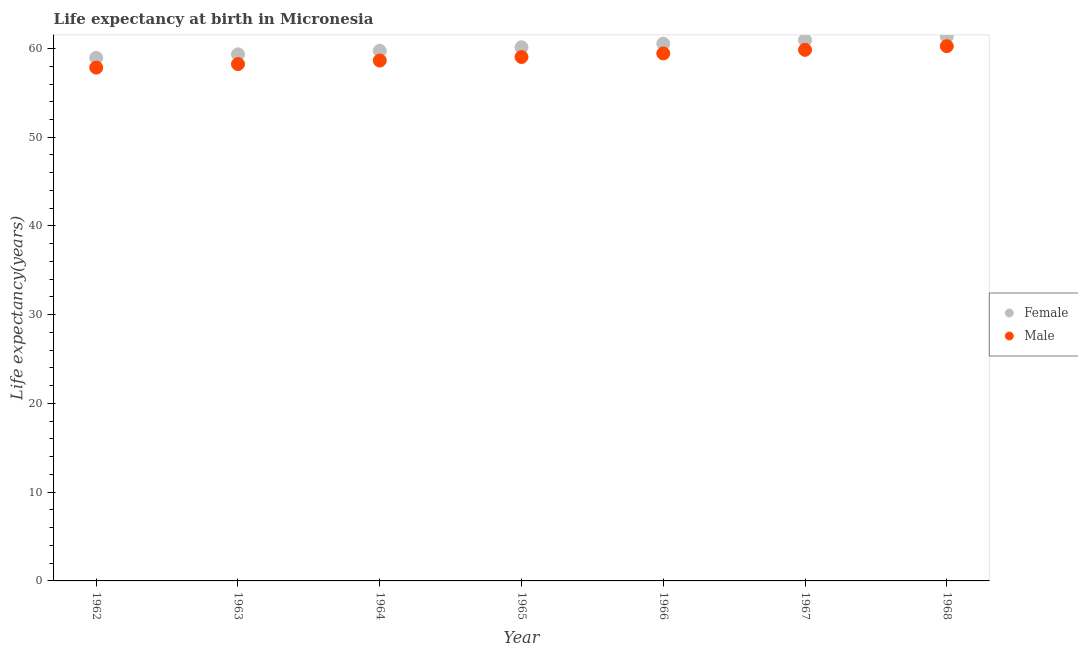What is the life expectancy(female) in 1962?
Your answer should be very brief. 58.95. Across all years, what is the maximum life expectancy(female)?
Keep it short and to the point. 61.36. Across all years, what is the minimum life expectancy(female)?
Give a very brief answer. 58.95. In which year was the life expectancy(female) maximum?
Provide a succinct answer. 1968. What is the total life expectancy(male) in the graph?
Your response must be concise. 413.33. What is the difference between the life expectancy(female) in 1962 and that in 1963?
Your answer should be compact. -0.4. What is the difference between the life expectancy(female) in 1967 and the life expectancy(male) in 1964?
Your response must be concise. 2.31. What is the average life expectancy(female) per year?
Provide a short and direct response. 60.15. In the year 1966, what is the difference between the life expectancy(female) and life expectancy(male)?
Provide a short and direct response. 1.1. In how many years, is the life expectancy(female) greater than 10 years?
Provide a succinct answer. 7. What is the ratio of the life expectancy(female) in 1962 to that in 1965?
Make the answer very short. 0.98. Is the life expectancy(male) in 1963 less than that in 1968?
Your answer should be very brief. Yes. What is the difference between the highest and the second highest life expectancy(male)?
Give a very brief answer. 0.41. What is the difference between the highest and the lowest life expectancy(female)?
Give a very brief answer. 2.41. In how many years, is the life expectancy(female) greater than the average life expectancy(female) taken over all years?
Provide a short and direct response. 3. Is the sum of the life expectancy(female) in 1963 and 1968 greater than the maximum life expectancy(male) across all years?
Give a very brief answer. Yes. Does the life expectancy(male) monotonically increase over the years?
Your response must be concise. Yes. Is the life expectancy(male) strictly less than the life expectancy(female) over the years?
Offer a very short reply. Yes. How many years are there in the graph?
Offer a terse response. 7. What is the difference between two consecutive major ticks on the Y-axis?
Your answer should be very brief. 10. Are the values on the major ticks of Y-axis written in scientific E-notation?
Provide a short and direct response. No. Does the graph contain any zero values?
Your response must be concise. No. How many legend labels are there?
Your answer should be very brief. 2. What is the title of the graph?
Offer a terse response. Life expectancy at birth in Micronesia. Does "Resident" appear as one of the legend labels in the graph?
Make the answer very short. No. What is the label or title of the X-axis?
Make the answer very short. Year. What is the label or title of the Y-axis?
Your answer should be compact. Life expectancy(years). What is the Life expectancy(years) in Female in 1962?
Give a very brief answer. 58.95. What is the Life expectancy(years) in Male in 1962?
Offer a very short reply. 57.85. What is the Life expectancy(years) of Female in 1963?
Your answer should be very brief. 59.34. What is the Life expectancy(years) in Male in 1963?
Offer a terse response. 58.24. What is the Life expectancy(years) in Female in 1964?
Provide a short and direct response. 59.74. What is the Life expectancy(years) of Male in 1964?
Make the answer very short. 58.64. What is the Life expectancy(years) of Female in 1965?
Offer a very short reply. 60.14. What is the Life expectancy(years) of Male in 1965?
Make the answer very short. 59.04. What is the Life expectancy(years) in Female in 1966?
Offer a terse response. 60.55. What is the Life expectancy(years) of Male in 1966?
Give a very brief answer. 59.45. What is the Life expectancy(years) in Female in 1967?
Provide a succinct answer. 60.95. What is the Life expectancy(years) in Male in 1967?
Provide a short and direct response. 59.85. What is the Life expectancy(years) in Female in 1968?
Provide a succinct answer. 61.36. What is the Life expectancy(years) in Male in 1968?
Ensure brevity in your answer.  60.26. Across all years, what is the maximum Life expectancy(years) in Female?
Make the answer very short. 61.36. Across all years, what is the maximum Life expectancy(years) of Male?
Your answer should be compact. 60.26. Across all years, what is the minimum Life expectancy(years) in Female?
Ensure brevity in your answer.  58.95. Across all years, what is the minimum Life expectancy(years) of Male?
Keep it short and to the point. 57.85. What is the total Life expectancy(years) in Female in the graph?
Ensure brevity in your answer.  421.03. What is the total Life expectancy(years) of Male in the graph?
Offer a very short reply. 413.33. What is the difference between the Life expectancy(years) of Female in 1962 and that in 1963?
Provide a succinct answer. -0.4. What is the difference between the Life expectancy(years) in Male in 1962 and that in 1963?
Your answer should be very brief. -0.4. What is the difference between the Life expectancy(years) of Female in 1962 and that in 1964?
Your answer should be very brief. -0.8. What is the difference between the Life expectancy(years) in Male in 1962 and that in 1964?
Provide a succinct answer. -0.8. What is the difference between the Life expectancy(years) of Female in 1962 and that in 1965?
Your answer should be very brief. -1.2. What is the difference between the Life expectancy(years) of Male in 1962 and that in 1965?
Ensure brevity in your answer.  -1.2. What is the difference between the Life expectancy(years) in Female in 1962 and that in 1966?
Ensure brevity in your answer.  -1.6. What is the difference between the Life expectancy(years) of Male in 1962 and that in 1966?
Your answer should be compact. -1.6. What is the difference between the Life expectancy(years) of Female in 1962 and that in 1967?
Provide a short and direct response. -2. What is the difference between the Life expectancy(years) in Male in 1962 and that in 1967?
Provide a succinct answer. -2. What is the difference between the Life expectancy(years) of Female in 1962 and that in 1968?
Your answer should be compact. -2.41. What is the difference between the Life expectancy(years) of Male in 1962 and that in 1968?
Offer a terse response. -2.41. What is the difference between the Life expectancy(years) of Female in 1963 and that in 1964?
Keep it short and to the point. -0.4. What is the difference between the Life expectancy(years) in Male in 1963 and that in 1964?
Your answer should be very brief. -0.4. What is the difference between the Life expectancy(years) of Female in 1963 and that in 1965?
Ensure brevity in your answer.  -0.8. What is the difference between the Life expectancy(years) in Male in 1963 and that in 1965?
Provide a short and direct response. -0.8. What is the difference between the Life expectancy(years) of Female in 1963 and that in 1967?
Make the answer very short. -1.61. What is the difference between the Life expectancy(years) in Male in 1963 and that in 1967?
Your answer should be very brief. -1.61. What is the difference between the Life expectancy(years) of Female in 1963 and that in 1968?
Give a very brief answer. -2.02. What is the difference between the Life expectancy(years) of Male in 1963 and that in 1968?
Your answer should be very brief. -2.02. What is the difference between the Life expectancy(years) in Female in 1964 and that in 1965?
Give a very brief answer. -0.4. What is the difference between the Life expectancy(years) of Male in 1964 and that in 1965?
Your answer should be compact. -0.4. What is the difference between the Life expectancy(years) in Female in 1964 and that in 1966?
Give a very brief answer. -0.8. What is the difference between the Life expectancy(years) of Male in 1964 and that in 1966?
Provide a succinct answer. -0.8. What is the difference between the Life expectancy(years) of Female in 1964 and that in 1967?
Provide a succinct answer. -1.21. What is the difference between the Life expectancy(years) in Male in 1964 and that in 1967?
Ensure brevity in your answer.  -1.21. What is the difference between the Life expectancy(years) of Female in 1964 and that in 1968?
Make the answer very short. -1.62. What is the difference between the Life expectancy(years) in Male in 1964 and that in 1968?
Keep it short and to the point. -1.62. What is the difference between the Life expectancy(years) of Female in 1965 and that in 1966?
Offer a terse response. -0.4. What is the difference between the Life expectancy(years) of Male in 1965 and that in 1966?
Provide a short and direct response. -0.4. What is the difference between the Life expectancy(years) of Female in 1965 and that in 1967?
Your response must be concise. -0.81. What is the difference between the Life expectancy(years) in Male in 1965 and that in 1967?
Make the answer very short. -0.81. What is the difference between the Life expectancy(years) in Female in 1965 and that in 1968?
Give a very brief answer. -1.22. What is the difference between the Life expectancy(years) of Male in 1965 and that in 1968?
Keep it short and to the point. -1.22. What is the difference between the Life expectancy(years) in Female in 1966 and that in 1967?
Provide a succinct answer. -0.41. What is the difference between the Life expectancy(years) of Male in 1966 and that in 1967?
Keep it short and to the point. -0.41. What is the difference between the Life expectancy(years) in Female in 1966 and that in 1968?
Offer a very short reply. -0.82. What is the difference between the Life expectancy(years) of Male in 1966 and that in 1968?
Offer a very short reply. -0.82. What is the difference between the Life expectancy(years) of Female in 1967 and that in 1968?
Offer a very short reply. -0.41. What is the difference between the Life expectancy(years) of Male in 1967 and that in 1968?
Give a very brief answer. -0.41. What is the difference between the Life expectancy(years) in Female in 1962 and the Life expectancy(years) in Male in 1963?
Provide a short and direct response. 0.7. What is the difference between the Life expectancy(years) of Female in 1962 and the Life expectancy(years) of Male in 1964?
Give a very brief answer. 0.3. What is the difference between the Life expectancy(years) in Female in 1962 and the Life expectancy(years) in Male in 1965?
Make the answer very short. -0.1. What is the difference between the Life expectancy(years) of Female in 1962 and the Life expectancy(years) of Male in 1966?
Keep it short and to the point. -0.5. What is the difference between the Life expectancy(years) of Female in 1962 and the Life expectancy(years) of Male in 1967?
Keep it short and to the point. -0.9. What is the difference between the Life expectancy(years) in Female in 1962 and the Life expectancy(years) in Male in 1968?
Your answer should be compact. -1.31. What is the difference between the Life expectancy(years) in Female in 1963 and the Life expectancy(years) in Male in 1964?
Provide a succinct answer. 0.7. What is the difference between the Life expectancy(years) of Female in 1963 and the Life expectancy(years) of Male in 1965?
Offer a very short reply. 0.3. What is the difference between the Life expectancy(years) in Female in 1963 and the Life expectancy(years) in Male in 1966?
Provide a succinct answer. -0.1. What is the difference between the Life expectancy(years) of Female in 1963 and the Life expectancy(years) of Male in 1967?
Give a very brief answer. -0.51. What is the difference between the Life expectancy(years) of Female in 1963 and the Life expectancy(years) of Male in 1968?
Your answer should be compact. -0.92. What is the difference between the Life expectancy(years) in Female in 1964 and the Life expectancy(years) in Male in 1965?
Your response must be concise. 0.7. What is the difference between the Life expectancy(years) of Female in 1964 and the Life expectancy(years) of Male in 1966?
Offer a very short reply. 0.3. What is the difference between the Life expectancy(years) of Female in 1964 and the Life expectancy(years) of Male in 1967?
Your response must be concise. -0.11. What is the difference between the Life expectancy(years) in Female in 1964 and the Life expectancy(years) in Male in 1968?
Offer a very short reply. -0.52. What is the difference between the Life expectancy(years) of Female in 1965 and the Life expectancy(years) of Male in 1966?
Provide a short and direct response. 0.7. What is the difference between the Life expectancy(years) in Female in 1965 and the Life expectancy(years) in Male in 1967?
Keep it short and to the point. 0.29. What is the difference between the Life expectancy(years) in Female in 1965 and the Life expectancy(years) in Male in 1968?
Ensure brevity in your answer.  -0.12. What is the difference between the Life expectancy(years) in Female in 1966 and the Life expectancy(years) in Male in 1967?
Provide a short and direct response. 0.69. What is the difference between the Life expectancy(years) of Female in 1966 and the Life expectancy(years) of Male in 1968?
Your response must be concise. 0.28. What is the difference between the Life expectancy(years) in Female in 1967 and the Life expectancy(years) in Male in 1968?
Provide a short and direct response. 0.69. What is the average Life expectancy(years) in Female per year?
Give a very brief answer. 60.15. What is the average Life expectancy(years) in Male per year?
Make the answer very short. 59.05. In the year 1963, what is the difference between the Life expectancy(years) in Female and Life expectancy(years) in Male?
Keep it short and to the point. 1.1. In the year 1966, what is the difference between the Life expectancy(years) in Female and Life expectancy(years) in Male?
Provide a short and direct response. 1.1. In the year 1968, what is the difference between the Life expectancy(years) of Female and Life expectancy(years) of Male?
Provide a succinct answer. 1.1. What is the ratio of the Life expectancy(years) of Female in 1962 to that in 1963?
Make the answer very short. 0.99. What is the ratio of the Life expectancy(years) in Male in 1962 to that in 1963?
Keep it short and to the point. 0.99. What is the ratio of the Life expectancy(years) of Female in 1962 to that in 1964?
Ensure brevity in your answer.  0.99. What is the ratio of the Life expectancy(years) of Male in 1962 to that in 1964?
Offer a terse response. 0.99. What is the ratio of the Life expectancy(years) of Female in 1962 to that in 1965?
Offer a terse response. 0.98. What is the ratio of the Life expectancy(years) in Male in 1962 to that in 1965?
Your response must be concise. 0.98. What is the ratio of the Life expectancy(years) of Female in 1962 to that in 1966?
Provide a succinct answer. 0.97. What is the ratio of the Life expectancy(years) of Male in 1962 to that in 1966?
Provide a succinct answer. 0.97. What is the ratio of the Life expectancy(years) in Female in 1962 to that in 1967?
Your answer should be very brief. 0.97. What is the ratio of the Life expectancy(years) in Male in 1962 to that in 1967?
Your answer should be very brief. 0.97. What is the ratio of the Life expectancy(years) in Female in 1962 to that in 1968?
Make the answer very short. 0.96. What is the ratio of the Life expectancy(years) in Male in 1962 to that in 1968?
Keep it short and to the point. 0.96. What is the ratio of the Life expectancy(years) of Male in 1963 to that in 1964?
Your answer should be very brief. 0.99. What is the ratio of the Life expectancy(years) in Female in 1963 to that in 1965?
Give a very brief answer. 0.99. What is the ratio of the Life expectancy(years) of Male in 1963 to that in 1965?
Keep it short and to the point. 0.99. What is the ratio of the Life expectancy(years) of Female in 1963 to that in 1966?
Make the answer very short. 0.98. What is the ratio of the Life expectancy(years) of Male in 1963 to that in 1966?
Provide a short and direct response. 0.98. What is the ratio of the Life expectancy(years) of Female in 1963 to that in 1967?
Your answer should be very brief. 0.97. What is the ratio of the Life expectancy(years) of Male in 1963 to that in 1967?
Offer a very short reply. 0.97. What is the ratio of the Life expectancy(years) of Female in 1963 to that in 1968?
Your answer should be very brief. 0.97. What is the ratio of the Life expectancy(years) of Male in 1963 to that in 1968?
Keep it short and to the point. 0.97. What is the ratio of the Life expectancy(years) in Male in 1964 to that in 1965?
Your answer should be very brief. 0.99. What is the ratio of the Life expectancy(years) of Female in 1964 to that in 1966?
Keep it short and to the point. 0.99. What is the ratio of the Life expectancy(years) in Male in 1964 to that in 1966?
Your answer should be compact. 0.99. What is the ratio of the Life expectancy(years) in Female in 1964 to that in 1967?
Your response must be concise. 0.98. What is the ratio of the Life expectancy(years) in Male in 1964 to that in 1967?
Your answer should be compact. 0.98. What is the ratio of the Life expectancy(years) of Female in 1964 to that in 1968?
Your answer should be compact. 0.97. What is the ratio of the Life expectancy(years) in Male in 1964 to that in 1968?
Offer a very short reply. 0.97. What is the ratio of the Life expectancy(years) in Female in 1965 to that in 1967?
Offer a terse response. 0.99. What is the ratio of the Life expectancy(years) of Male in 1965 to that in 1967?
Your response must be concise. 0.99. What is the ratio of the Life expectancy(years) in Female in 1965 to that in 1968?
Your answer should be compact. 0.98. What is the ratio of the Life expectancy(years) in Male in 1965 to that in 1968?
Provide a succinct answer. 0.98. What is the ratio of the Life expectancy(years) in Male in 1966 to that in 1967?
Your response must be concise. 0.99. What is the ratio of the Life expectancy(years) of Female in 1966 to that in 1968?
Your answer should be very brief. 0.99. What is the ratio of the Life expectancy(years) of Male in 1966 to that in 1968?
Make the answer very short. 0.99. What is the ratio of the Life expectancy(years) of Female in 1967 to that in 1968?
Keep it short and to the point. 0.99. What is the difference between the highest and the second highest Life expectancy(years) in Female?
Offer a very short reply. 0.41. What is the difference between the highest and the second highest Life expectancy(years) of Male?
Your answer should be compact. 0.41. What is the difference between the highest and the lowest Life expectancy(years) of Female?
Keep it short and to the point. 2.41. What is the difference between the highest and the lowest Life expectancy(years) in Male?
Your answer should be compact. 2.41. 